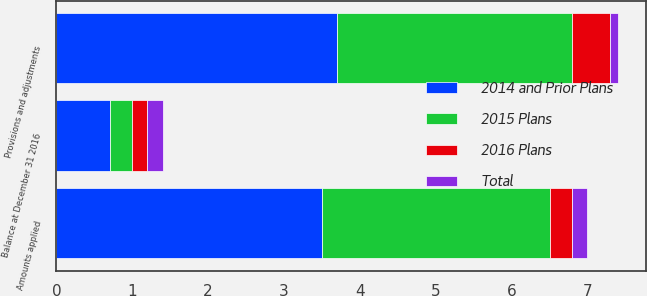<chart> <loc_0><loc_0><loc_500><loc_500><stacked_bar_chart><ecel><fcel>Provisions and adjustments<fcel>Amounts applied<fcel>Balance at December 31 2016<nl><fcel>Total<fcel>0.1<fcel>0.2<fcel>0.2<nl><fcel>2015 Plans<fcel>3.1<fcel>3<fcel>0.3<nl><fcel>2016 Plans<fcel>0.5<fcel>0.3<fcel>0.2<nl><fcel>2014 and Prior Plans<fcel>3.7<fcel>3.5<fcel>0.7<nl></chart> 